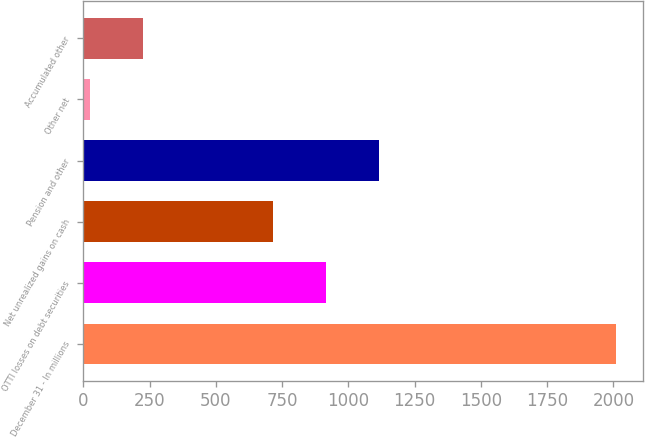Convert chart to OTSL. <chart><loc_0><loc_0><loc_500><loc_500><bar_chart><fcel>December 31 - In millions<fcel>OTTI losses on debt securities<fcel>Net unrealized gains on cash<fcel>Pension and other<fcel>Other net<fcel>Accumulated other<nl><fcel>2011<fcel>915.6<fcel>717<fcel>1114.2<fcel>25<fcel>223.6<nl></chart> 